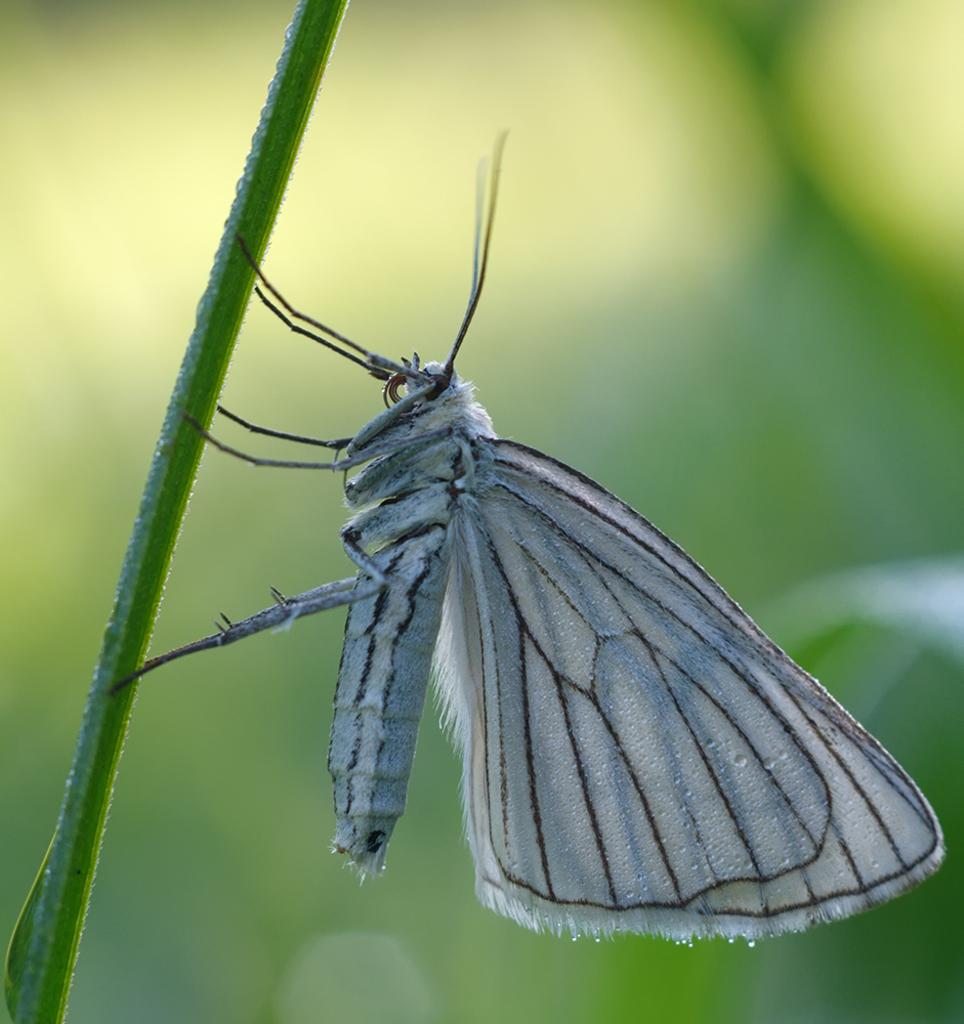What is the main subject in the image? There is a butterfly in the image. Where is the butterfly located in the image? The butterfly is standing on the stem of a plant. What type of wrench is being used to hold the butterfly in place in the image? There is no wrench present in the image, and the butterfly is not being held in place by any tool. 